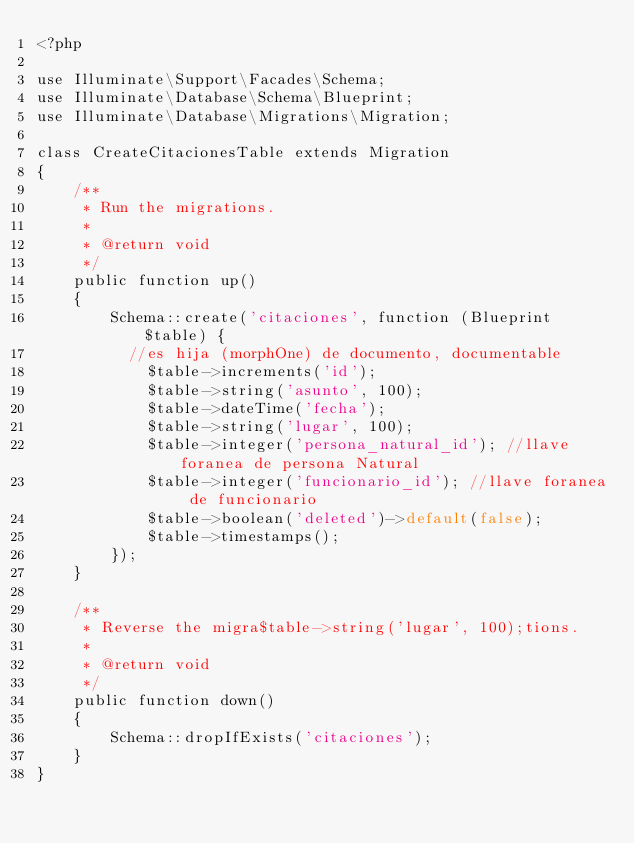<code> <loc_0><loc_0><loc_500><loc_500><_PHP_><?php

use Illuminate\Support\Facades\Schema;
use Illuminate\Database\Schema\Blueprint;
use Illuminate\Database\Migrations\Migration;

class CreateCitacionesTable extends Migration
{
    /**
     * Run the migrations.
     *
     * @return void
     */
    public function up()
    {
        Schema::create('citaciones', function (Blueprint $table) {
          //es hija (morphOne) de documento, documentable
            $table->increments('id');
            $table->string('asunto', 100);            
            $table->dateTime('fecha');
            $table->string('lugar', 100);
            $table->integer('persona_natural_id'); //llave foranea de persona Natural
            $table->integer('funcionario_id'); //llave foranea de funcionario
            $table->boolean('deleted')->default(false);
            $table->timestamps();
        });
    }

    /**
     * Reverse the migra$table->string('lugar', 100);tions.
     *
     * @return void
     */
    public function down()
    {
        Schema::dropIfExists('citaciones');
    }
}
</code> 